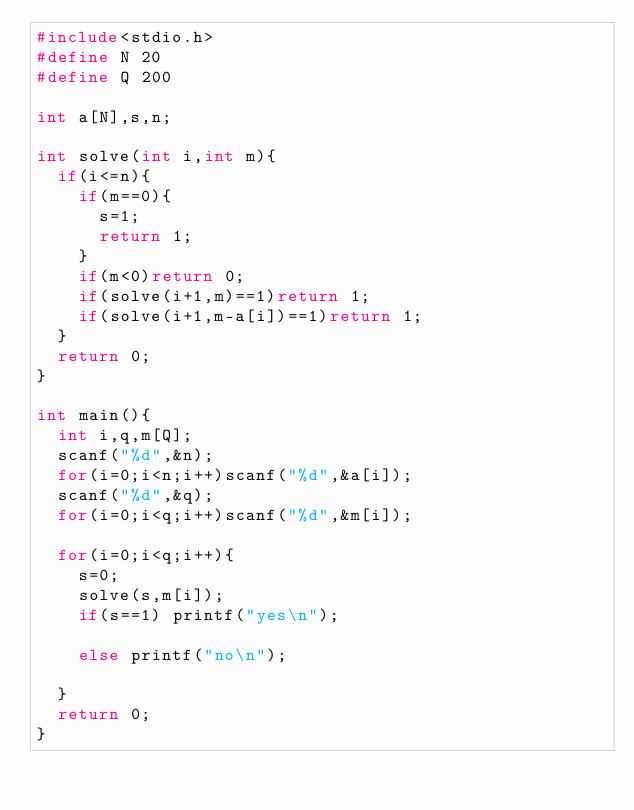Convert code to text. <code><loc_0><loc_0><loc_500><loc_500><_C_>#include<stdio.h>
#define N 20
#define Q 200

int a[N],s,n;

int solve(int i,int m){
  if(i<=n){
    if(m==0){
      s=1;
      return 1;
    }
    if(m<0)return 0;
    if(solve(i+1,m)==1)return 1;
    if(solve(i+1,m-a[i])==1)return 1;
  }
  return 0;
}

int main(){
  int i,q,m[Q];
  scanf("%d",&n);
  for(i=0;i<n;i++)scanf("%d",&a[i]);
  scanf("%d",&q);
  for(i=0;i<q;i++)scanf("%d",&m[i]);
  
  for(i=0;i<q;i++){
    s=0;
    solve(s,m[i]);
    if(s==1) printf("yes\n");
    
    else printf("no\n");
    
  }
  return 0;
}</code> 